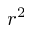<formula> <loc_0><loc_0><loc_500><loc_500>r ^ { 2 }</formula> 